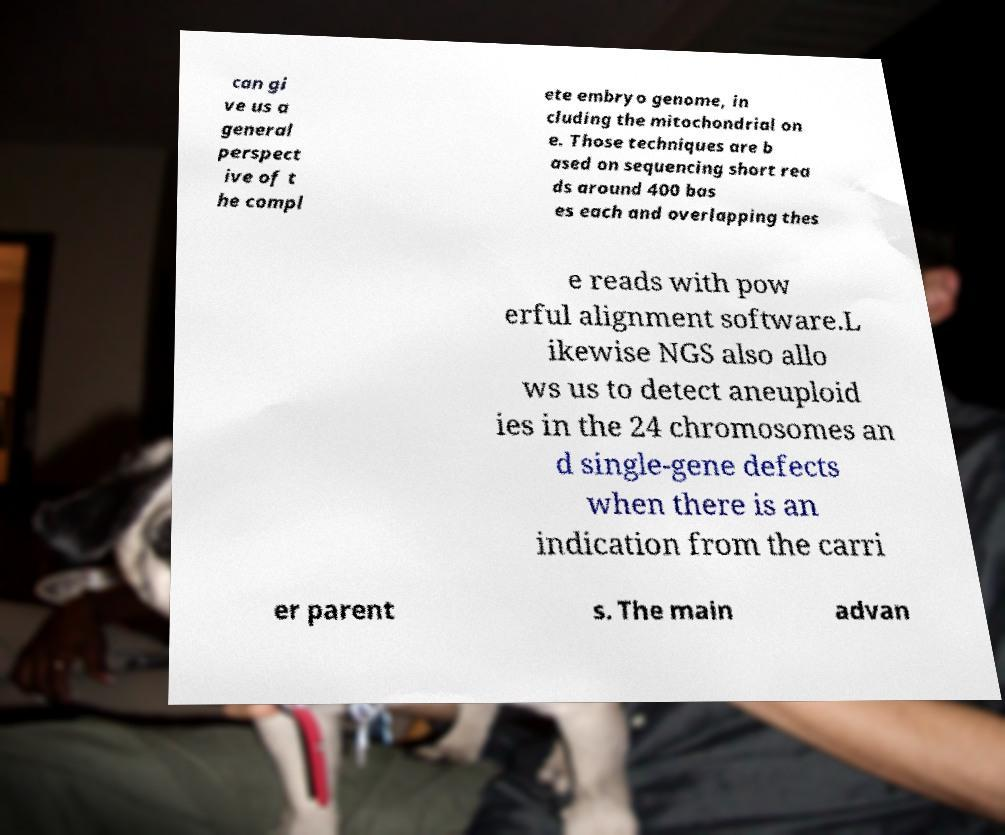For documentation purposes, I need the text within this image transcribed. Could you provide that? can gi ve us a general perspect ive of t he compl ete embryo genome, in cluding the mitochondrial on e. Those techniques are b ased on sequencing short rea ds around 400 bas es each and overlapping thes e reads with pow erful alignment software.L ikewise NGS also allo ws us to detect aneuploid ies in the 24 chromosomes an d single-gene defects when there is an indication from the carri er parent s. The main advan 